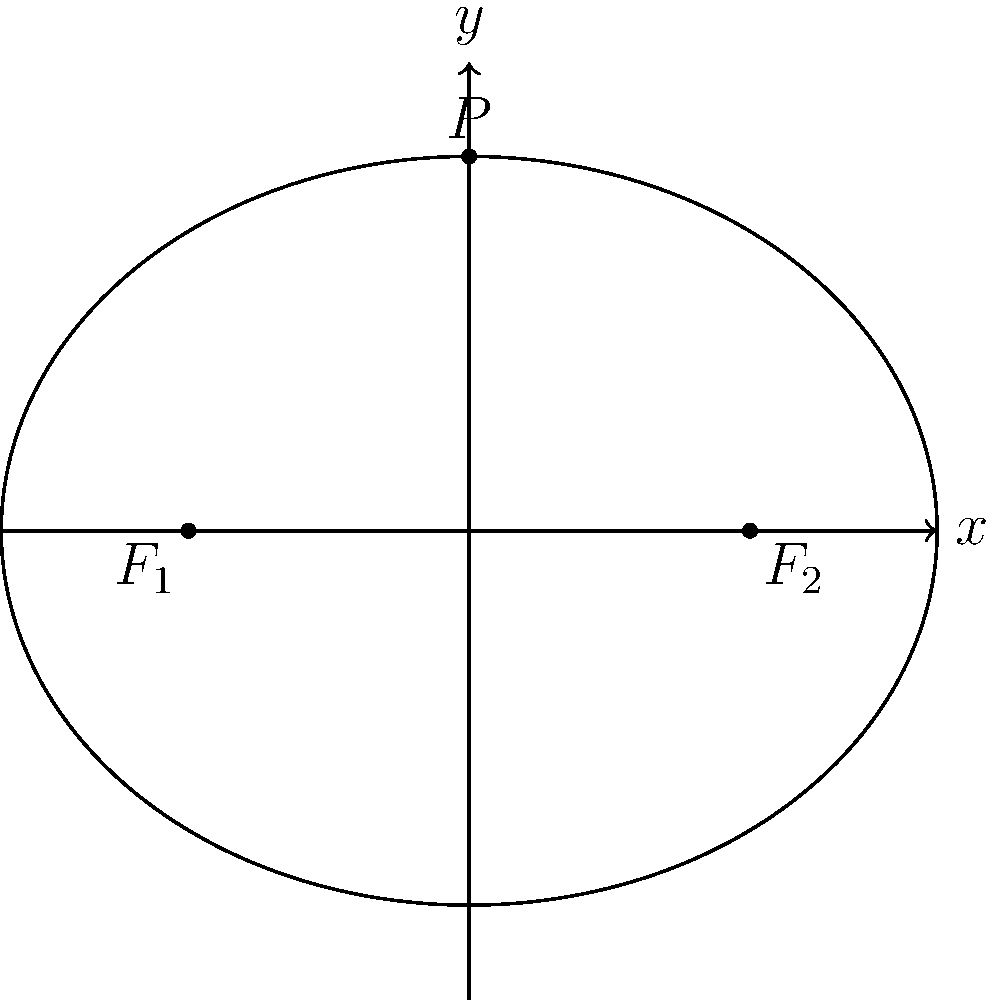En una escena de la película clásica "Los olvidados" de Luis Buñuel, se muestra una elipse que representa el camino de un personaje. Los focos de esta elipse están ubicados en los puntos $F_1(-3,0)$ y $F_2(3,0)$, y un punto $P(0,4)$ se encuentra en la curva. Determine la ecuación de esta elipse, relacionando así la precisión matemática con la narrativa cinematográfica de Buñuel. Para encontrar la ecuación de la elipse, seguiremos estos pasos:

1) La forma general de la ecuación de una elipse con centro en el origen es:

   $$\frac{x^2}{a^2} + \frac{y^2}{b^2} = 1$$

   donde $a$ es el semieje mayor y $b$ es el semieje menor.

2) La distancia entre los focos es $2c = 6$, por lo que $c = 3$.

3) Sabemos que $a^2 = b^2 + c^2$ en una elipse.

4) El punto $P(0,4)$ está en la elipse, por lo que $b = 4$.

5) Calculemos $a$:
   $$a^2 = b^2 + c^2 = 4^2 + 3^2 = 16 + 9 = 25$$
   $$a = 5$$

6) Ahora podemos escribir la ecuación sustituyendo los valores:

   $$\frac{x^2}{25} + \frac{y^2}{16} = 1$$

Esta ecuación representa la elipse que Buñuel pudo haber utilizado simbólicamente para representar el camino circular pero imperfecto de sus personajes, reflejando la complejidad de la vida en sus obras maestras del cine.
Answer: $$\frac{x^2}{25} + \frac{y^2}{16} = 1$$ 